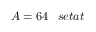Convert formula to latex. <formula><loc_0><loc_0><loc_500><loc_500>A = 6 4 \, s e t a t</formula> 